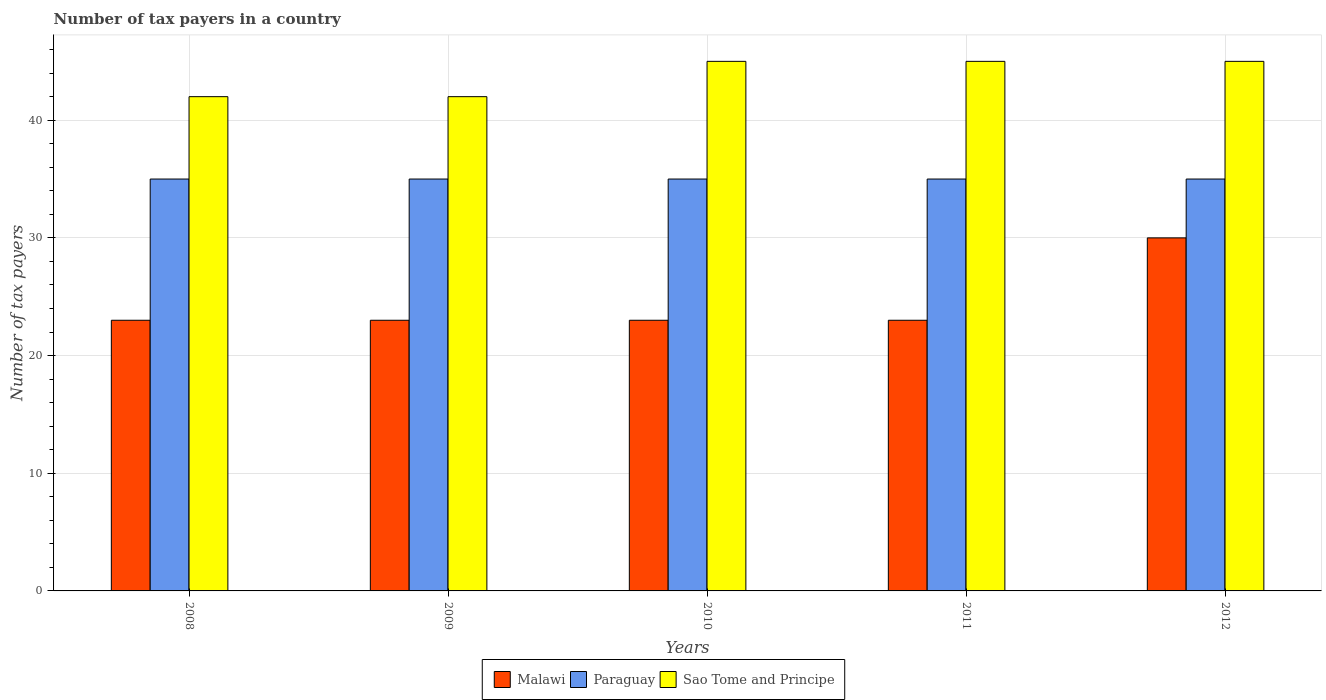How many different coloured bars are there?
Offer a terse response. 3. How many groups of bars are there?
Your answer should be very brief. 5. How many bars are there on the 3rd tick from the right?
Offer a terse response. 3. In how many cases, is the number of bars for a given year not equal to the number of legend labels?
Keep it short and to the point. 0. What is the number of tax payers in in Paraguay in 2011?
Your answer should be compact. 35. Across all years, what is the maximum number of tax payers in in Paraguay?
Offer a very short reply. 35. Across all years, what is the minimum number of tax payers in in Sao Tome and Principe?
Give a very brief answer. 42. What is the total number of tax payers in in Sao Tome and Principe in the graph?
Keep it short and to the point. 219. What is the difference between the number of tax payers in in Sao Tome and Principe in 2008 and that in 2010?
Your answer should be compact. -3. What is the difference between the number of tax payers in in Sao Tome and Principe in 2011 and the number of tax payers in in Malawi in 2010?
Provide a succinct answer. 22. What is the average number of tax payers in in Malawi per year?
Give a very brief answer. 24.4. In the year 2010, what is the difference between the number of tax payers in in Paraguay and number of tax payers in in Malawi?
Your answer should be compact. 12. In how many years, is the number of tax payers in in Sao Tome and Principe greater than 10?
Ensure brevity in your answer.  5. What is the ratio of the number of tax payers in in Malawi in 2009 to that in 2010?
Give a very brief answer. 1. What is the difference between the highest and the second highest number of tax payers in in Sao Tome and Principe?
Keep it short and to the point. 0. What is the difference between the highest and the lowest number of tax payers in in Malawi?
Give a very brief answer. 7. Is the sum of the number of tax payers in in Sao Tome and Principe in 2009 and 2011 greater than the maximum number of tax payers in in Malawi across all years?
Keep it short and to the point. Yes. What does the 3rd bar from the left in 2010 represents?
Ensure brevity in your answer.  Sao Tome and Principe. What does the 3rd bar from the right in 2010 represents?
Your answer should be very brief. Malawi. How many bars are there?
Provide a short and direct response. 15. Are the values on the major ticks of Y-axis written in scientific E-notation?
Provide a succinct answer. No. Does the graph contain any zero values?
Give a very brief answer. No. Where does the legend appear in the graph?
Make the answer very short. Bottom center. How many legend labels are there?
Give a very brief answer. 3. How are the legend labels stacked?
Make the answer very short. Horizontal. What is the title of the graph?
Offer a terse response. Number of tax payers in a country. Does "Panama" appear as one of the legend labels in the graph?
Provide a succinct answer. No. What is the label or title of the X-axis?
Your response must be concise. Years. What is the label or title of the Y-axis?
Make the answer very short. Number of tax payers. What is the Number of tax payers in Malawi in 2008?
Your answer should be compact. 23. What is the Number of tax payers of Paraguay in 2008?
Your response must be concise. 35. What is the Number of tax payers of Sao Tome and Principe in 2008?
Your answer should be compact. 42. What is the Number of tax payers in Sao Tome and Principe in 2009?
Provide a short and direct response. 42. What is the Number of tax payers of Malawi in 2010?
Give a very brief answer. 23. What is the Number of tax payers in Sao Tome and Principe in 2010?
Offer a very short reply. 45. What is the Number of tax payers in Malawi in 2011?
Provide a succinct answer. 23. What is the Number of tax payers in Sao Tome and Principe in 2011?
Offer a terse response. 45. What is the Number of tax payers of Malawi in 2012?
Provide a short and direct response. 30. What is the Number of tax payers of Paraguay in 2012?
Ensure brevity in your answer.  35. What is the Number of tax payers in Sao Tome and Principe in 2012?
Make the answer very short. 45. Across all years, what is the maximum Number of tax payers in Malawi?
Ensure brevity in your answer.  30. Across all years, what is the maximum Number of tax payers in Paraguay?
Keep it short and to the point. 35. Across all years, what is the maximum Number of tax payers of Sao Tome and Principe?
Offer a very short reply. 45. Across all years, what is the minimum Number of tax payers of Malawi?
Provide a succinct answer. 23. Across all years, what is the minimum Number of tax payers in Sao Tome and Principe?
Provide a short and direct response. 42. What is the total Number of tax payers of Malawi in the graph?
Make the answer very short. 122. What is the total Number of tax payers in Paraguay in the graph?
Make the answer very short. 175. What is the total Number of tax payers of Sao Tome and Principe in the graph?
Provide a short and direct response. 219. What is the difference between the Number of tax payers of Sao Tome and Principe in 2008 and that in 2009?
Ensure brevity in your answer.  0. What is the difference between the Number of tax payers of Paraguay in 2008 and that in 2010?
Provide a succinct answer. 0. What is the difference between the Number of tax payers in Malawi in 2008 and that in 2012?
Keep it short and to the point. -7. What is the difference between the Number of tax payers in Sao Tome and Principe in 2008 and that in 2012?
Provide a short and direct response. -3. What is the difference between the Number of tax payers in Malawi in 2009 and that in 2010?
Keep it short and to the point. 0. What is the difference between the Number of tax payers of Paraguay in 2009 and that in 2010?
Offer a very short reply. 0. What is the difference between the Number of tax payers of Sao Tome and Principe in 2009 and that in 2010?
Your answer should be compact. -3. What is the difference between the Number of tax payers in Malawi in 2009 and that in 2011?
Make the answer very short. 0. What is the difference between the Number of tax payers in Sao Tome and Principe in 2009 and that in 2011?
Offer a very short reply. -3. What is the difference between the Number of tax payers of Malawi in 2009 and that in 2012?
Offer a terse response. -7. What is the difference between the Number of tax payers in Paraguay in 2009 and that in 2012?
Ensure brevity in your answer.  0. What is the difference between the Number of tax payers in Malawi in 2010 and that in 2011?
Provide a succinct answer. 0. What is the difference between the Number of tax payers of Paraguay in 2010 and that in 2011?
Offer a terse response. 0. What is the difference between the Number of tax payers of Malawi in 2010 and that in 2012?
Give a very brief answer. -7. What is the difference between the Number of tax payers in Malawi in 2011 and that in 2012?
Offer a very short reply. -7. What is the difference between the Number of tax payers in Sao Tome and Principe in 2011 and that in 2012?
Make the answer very short. 0. What is the difference between the Number of tax payers of Malawi in 2008 and the Number of tax payers of Paraguay in 2009?
Keep it short and to the point. -12. What is the difference between the Number of tax payers of Malawi in 2008 and the Number of tax payers of Paraguay in 2010?
Make the answer very short. -12. What is the difference between the Number of tax payers in Malawi in 2008 and the Number of tax payers in Sao Tome and Principe in 2010?
Keep it short and to the point. -22. What is the difference between the Number of tax payers of Malawi in 2008 and the Number of tax payers of Sao Tome and Principe in 2011?
Your response must be concise. -22. What is the difference between the Number of tax payers in Paraguay in 2009 and the Number of tax payers in Sao Tome and Principe in 2011?
Your response must be concise. -10. What is the difference between the Number of tax payers of Malawi in 2009 and the Number of tax payers of Sao Tome and Principe in 2012?
Ensure brevity in your answer.  -22. What is the difference between the Number of tax payers of Paraguay in 2009 and the Number of tax payers of Sao Tome and Principe in 2012?
Your response must be concise. -10. What is the difference between the Number of tax payers in Malawi in 2010 and the Number of tax payers in Sao Tome and Principe in 2012?
Your response must be concise. -22. What is the difference between the Number of tax payers of Paraguay in 2010 and the Number of tax payers of Sao Tome and Principe in 2012?
Ensure brevity in your answer.  -10. What is the average Number of tax payers in Malawi per year?
Give a very brief answer. 24.4. What is the average Number of tax payers in Sao Tome and Principe per year?
Your response must be concise. 43.8. In the year 2008, what is the difference between the Number of tax payers of Malawi and Number of tax payers of Paraguay?
Ensure brevity in your answer.  -12. In the year 2008, what is the difference between the Number of tax payers in Malawi and Number of tax payers in Sao Tome and Principe?
Make the answer very short. -19. In the year 2009, what is the difference between the Number of tax payers in Malawi and Number of tax payers in Paraguay?
Your answer should be compact. -12. In the year 2010, what is the difference between the Number of tax payers in Malawi and Number of tax payers in Paraguay?
Provide a short and direct response. -12. In the year 2010, what is the difference between the Number of tax payers in Malawi and Number of tax payers in Sao Tome and Principe?
Your response must be concise. -22. In the year 2011, what is the difference between the Number of tax payers of Malawi and Number of tax payers of Sao Tome and Principe?
Offer a very short reply. -22. In the year 2011, what is the difference between the Number of tax payers of Paraguay and Number of tax payers of Sao Tome and Principe?
Your answer should be compact. -10. In the year 2012, what is the difference between the Number of tax payers of Malawi and Number of tax payers of Paraguay?
Provide a succinct answer. -5. In the year 2012, what is the difference between the Number of tax payers in Malawi and Number of tax payers in Sao Tome and Principe?
Keep it short and to the point. -15. What is the ratio of the Number of tax payers in Sao Tome and Principe in 2008 to that in 2009?
Keep it short and to the point. 1. What is the ratio of the Number of tax payers in Malawi in 2008 to that in 2010?
Your answer should be compact. 1. What is the ratio of the Number of tax payers in Sao Tome and Principe in 2008 to that in 2010?
Offer a very short reply. 0.93. What is the ratio of the Number of tax payers of Malawi in 2008 to that in 2011?
Keep it short and to the point. 1. What is the ratio of the Number of tax payers in Malawi in 2008 to that in 2012?
Offer a very short reply. 0.77. What is the ratio of the Number of tax payers of Paraguay in 2008 to that in 2012?
Provide a succinct answer. 1. What is the ratio of the Number of tax payers in Malawi in 2009 to that in 2010?
Offer a very short reply. 1. What is the ratio of the Number of tax payers of Paraguay in 2009 to that in 2010?
Keep it short and to the point. 1. What is the ratio of the Number of tax payers of Malawi in 2009 to that in 2011?
Provide a succinct answer. 1. What is the ratio of the Number of tax payers in Sao Tome and Principe in 2009 to that in 2011?
Offer a very short reply. 0.93. What is the ratio of the Number of tax payers of Malawi in 2009 to that in 2012?
Ensure brevity in your answer.  0.77. What is the ratio of the Number of tax payers of Paraguay in 2009 to that in 2012?
Offer a very short reply. 1. What is the ratio of the Number of tax payers in Sao Tome and Principe in 2009 to that in 2012?
Make the answer very short. 0.93. What is the ratio of the Number of tax payers of Malawi in 2010 to that in 2011?
Your response must be concise. 1. What is the ratio of the Number of tax payers in Sao Tome and Principe in 2010 to that in 2011?
Ensure brevity in your answer.  1. What is the ratio of the Number of tax payers of Malawi in 2010 to that in 2012?
Offer a very short reply. 0.77. What is the ratio of the Number of tax payers of Malawi in 2011 to that in 2012?
Ensure brevity in your answer.  0.77. What is the difference between the highest and the second highest Number of tax payers in Paraguay?
Your answer should be very brief. 0. What is the difference between the highest and the second highest Number of tax payers of Sao Tome and Principe?
Keep it short and to the point. 0. What is the difference between the highest and the lowest Number of tax payers in Paraguay?
Give a very brief answer. 0. What is the difference between the highest and the lowest Number of tax payers of Sao Tome and Principe?
Provide a succinct answer. 3. 